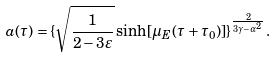<formula> <loc_0><loc_0><loc_500><loc_500>a ( \tau ) = \{ \sqrt { \frac { 1 } { 2 - 3 \varepsilon } } \sinh [ \mu _ { E } ( \tau + \tau _ { 0 } ) ] \} ^ { \frac { 2 } { 3 \gamma - \alpha ^ { 2 } } } .</formula> 